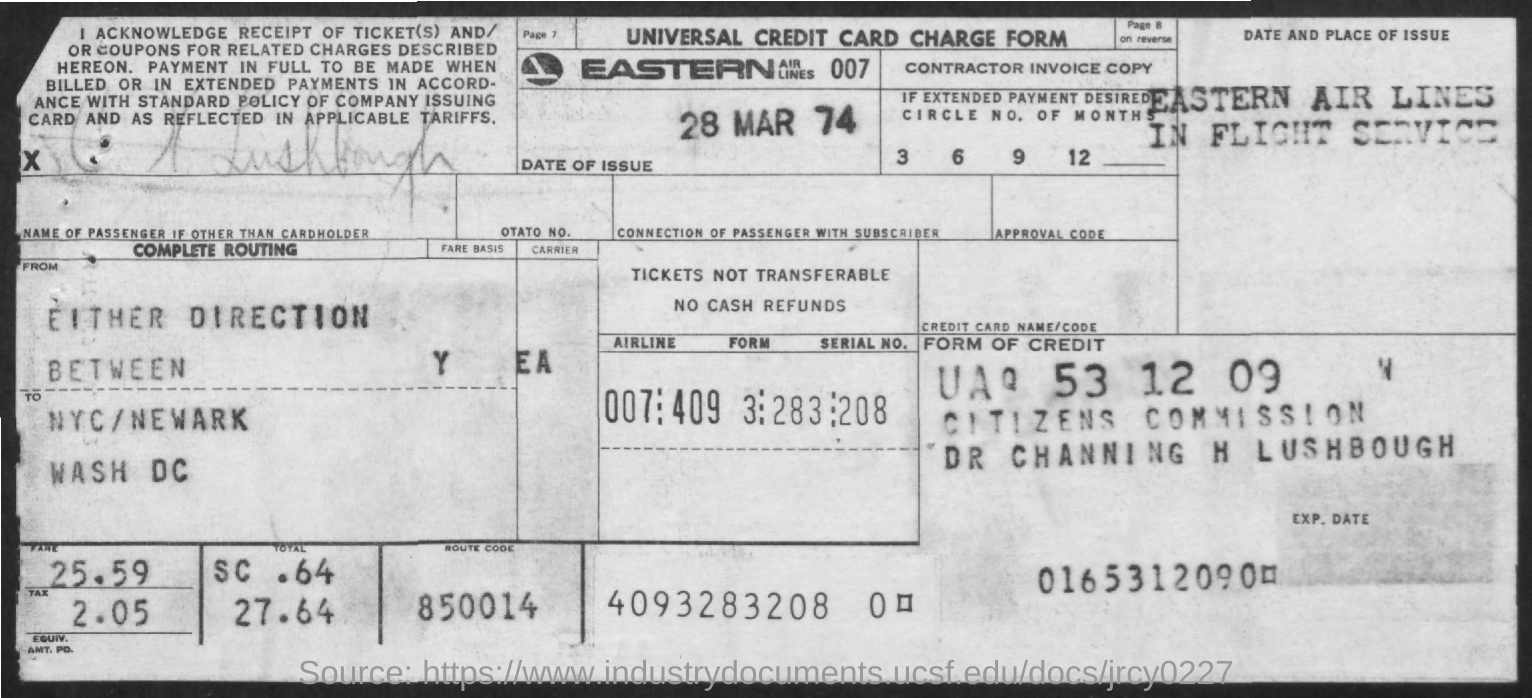Outline some significant characteristics in this image. The tax amount is 2.05. The fare is 25.59. The name of the airline is Eastern Airlines. The route code is 850014. The date of the issue is March 28, 1974. 